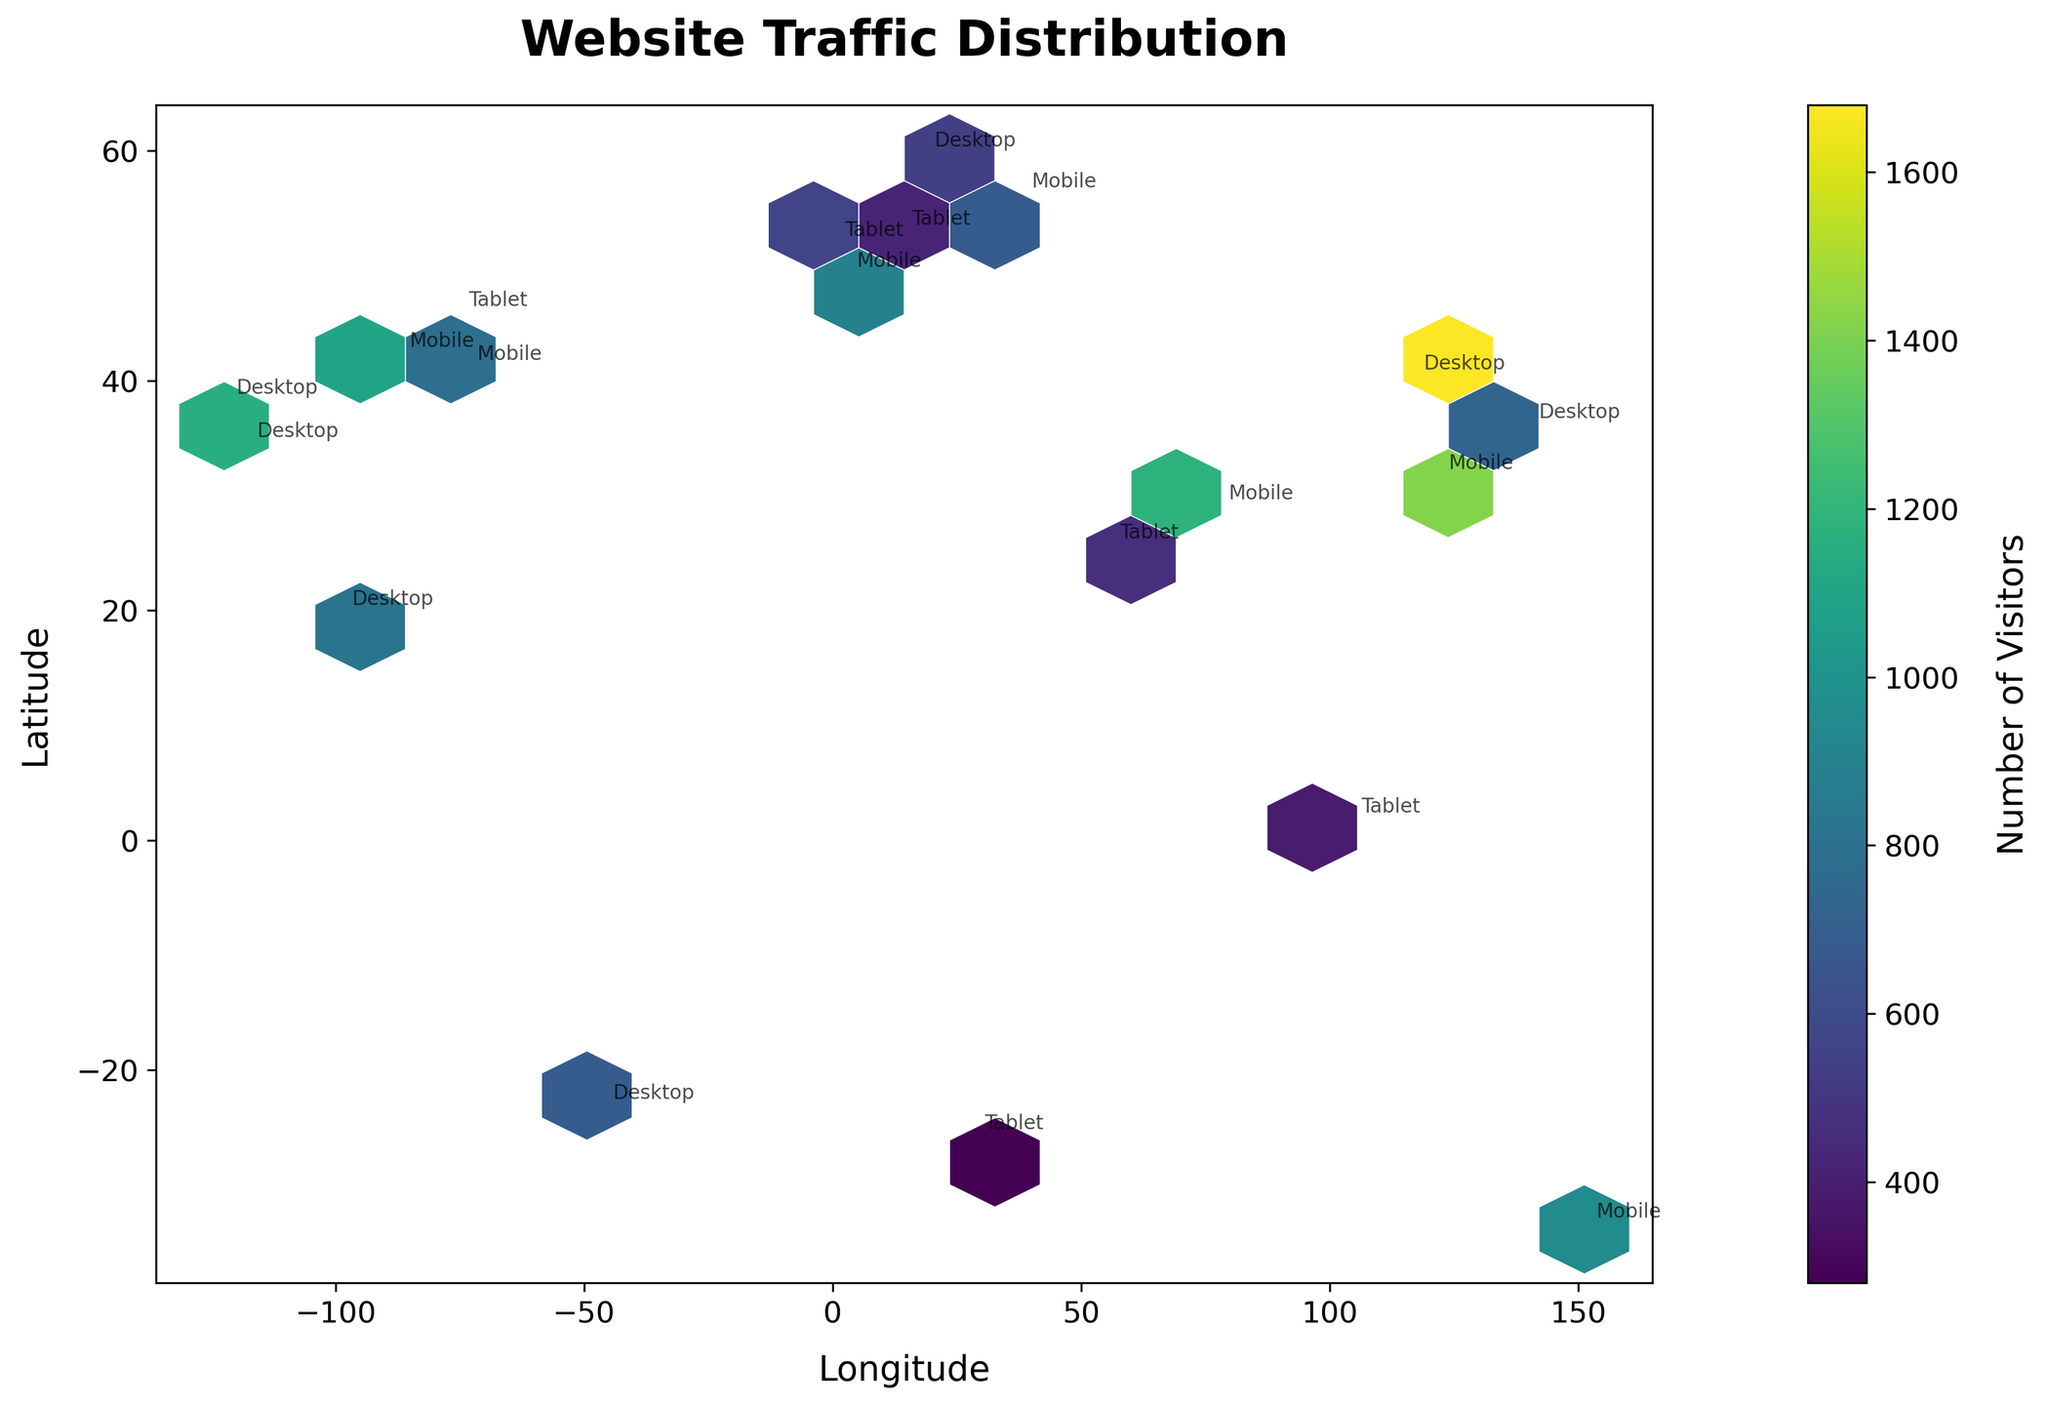What's the title of the figure? The title of the figure is prominently displayed at the top and reads "Website Traffic Distribution".
Answer: Website Traffic Distribution What are the labels on the x-axis and y-axis? The x-axis label is "Longitude" and the y-axis label is "Latitude". This can be seen directly on the plot along the respective axes.
Answer: Longitude, Latitude What color represents the highest number of visitors on the plot? On the hexbin plot, the color map used is 'viridis', where the highest number of visitors is represented by the brightest yellow color.
Answer: Bright Yellow How many device types are annotated on the plot? The plot has annotations for each data point indicating the device type, and there are three distinct device types: Mobile, Desktop, and Tablet.
Answer: Three Which location has the highest number of visitors, and what device type is associated with it? The location with the highest number of visitors is identified by the brightest yellow hexagon. According to the annotations, the location is at (39.9042, 116.4074) in Beijing, and the device type is Desktop.
Answer: Beijing, Desktop What is the median number of visitors for Desktop devices? To determine the median, first list the visitor numbers for Desktop devices: 980, 730, 1350, 820, 680, 1680. When ordered: 680, 730, 820, 980, 1350, 1680. The median is the average of the two middle numbers: (820 + 980) / 2 = 900.
Answer: 900 Among the three device types, which one has the highest average number of visitors? Calculate the average visitors for each device type. Mobile: (1250 + 890 + 1100 + 680 + 950 + 1420 + 1180) / 7 = 1070. Tablet: (560 + 420 + 390 + 470 + 310 + 280) / 6 = 405. Desktop: (980 + 730 + 1350 + 820 + 680 + 1680) / 6 = 1035. The Mobile devices have the highest average number.
Answer: Mobile Which city in Europe has the highest number of visitors, and what device type is used? Among the European cities on the plot (London, Berlin, Paris, and Moscow), find the city with the highest number of visitors. Paris with 890 (Mobile), London with 560 (Tablet), Berlin with 420 (Tablet), and Moscow with 680 (Mobile).
Answer: Paris, Mobile Does the majority of website traffic in Asia come from Mobile or Desktop devices? Look at the visitor numbers for Mobile (Tokyo - 1390, Beijing - 1420, Delhi - 1180) and Desktop (Tokyo - 730, Beijing - 1680, Delhi - none). Add up each: Mobile: 1390 + 1420 + 1180 = 3990. Desktop: 730 + 1680 = 2410. The majority of traffic in Asia comes from Mobile devices.
Answer: Mobile Comparing the traffic from North America to Europe, which continent has more visitors on average for Mobile devices? In North America: New York - 1250, Chicago - 1100, Toronto - none, Mobile total: 1250 + 1100 = 2350, average = 2350/2 = 1175. In Europe: London - none, Berlin - none, Paris - 890, Moscow - 680, Mobile total: 890 + 680 = 1570, average = 1570/2 = 785. North America has a higher average.
Answer: North America 